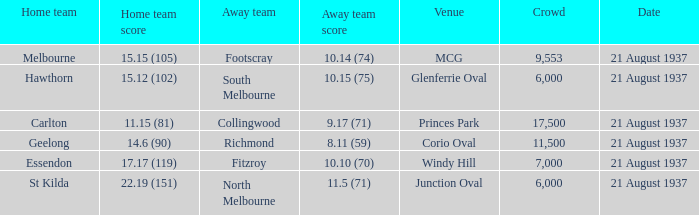Where did Richmond play? Corio Oval. 